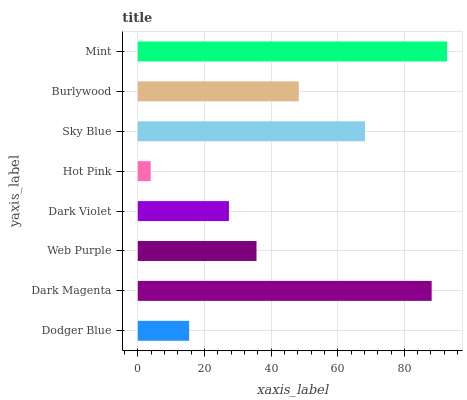Is Hot Pink the minimum?
Answer yes or no. Yes. Is Mint the maximum?
Answer yes or no. Yes. Is Dark Magenta the minimum?
Answer yes or no. No. Is Dark Magenta the maximum?
Answer yes or no. No. Is Dark Magenta greater than Dodger Blue?
Answer yes or no. Yes. Is Dodger Blue less than Dark Magenta?
Answer yes or no. Yes. Is Dodger Blue greater than Dark Magenta?
Answer yes or no. No. Is Dark Magenta less than Dodger Blue?
Answer yes or no. No. Is Burlywood the high median?
Answer yes or no. Yes. Is Web Purple the low median?
Answer yes or no. Yes. Is Dark Magenta the high median?
Answer yes or no. No. Is Dark Magenta the low median?
Answer yes or no. No. 